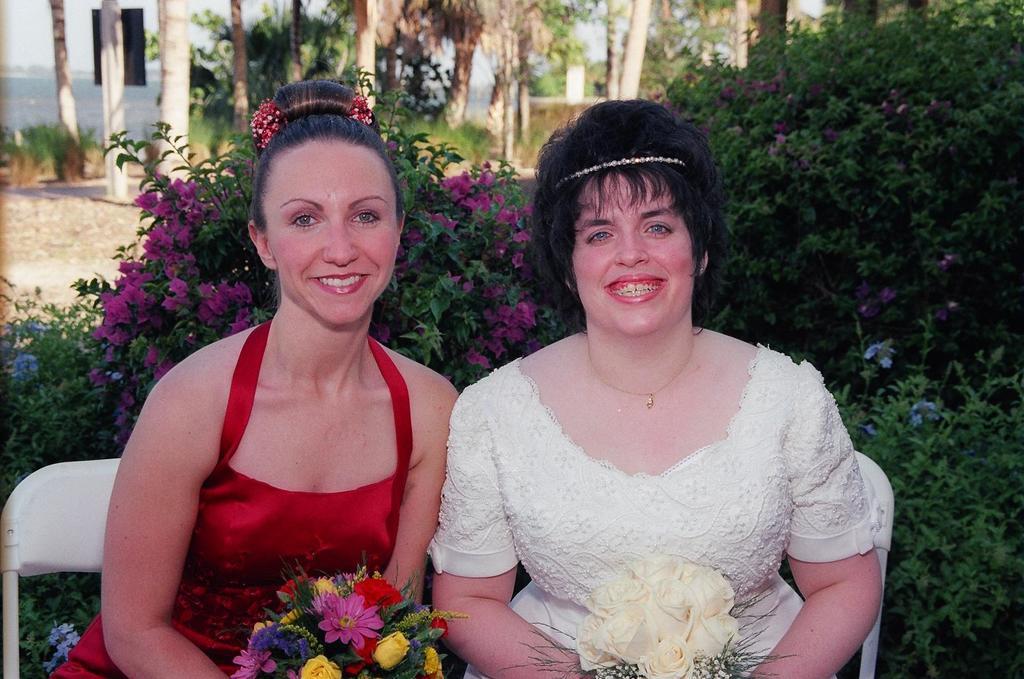Describe this image in one or two sentences. In the image in the center we can see two persons were sitting on the chair and they were holding bouquet. And we can see they were smiling,which we can see on their faces. In the background there is a building,wall,trees,plants,grass and flowers. 